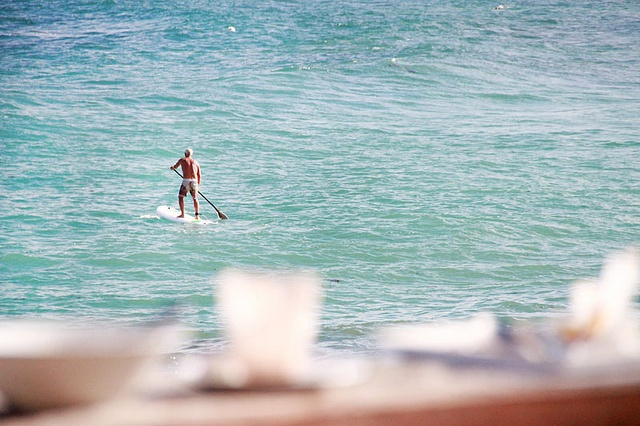Describe the objects in this image and their specific colors. I can see bowl in blue, lightgray, gray, darkgray, and tan tones, cup in blue, white, lightgray, and darkgray tones, people in blue, lightgray, maroon, darkgray, and brown tones, and surfboard in blue, white, lightblue, darkgray, and turquoise tones in this image. 